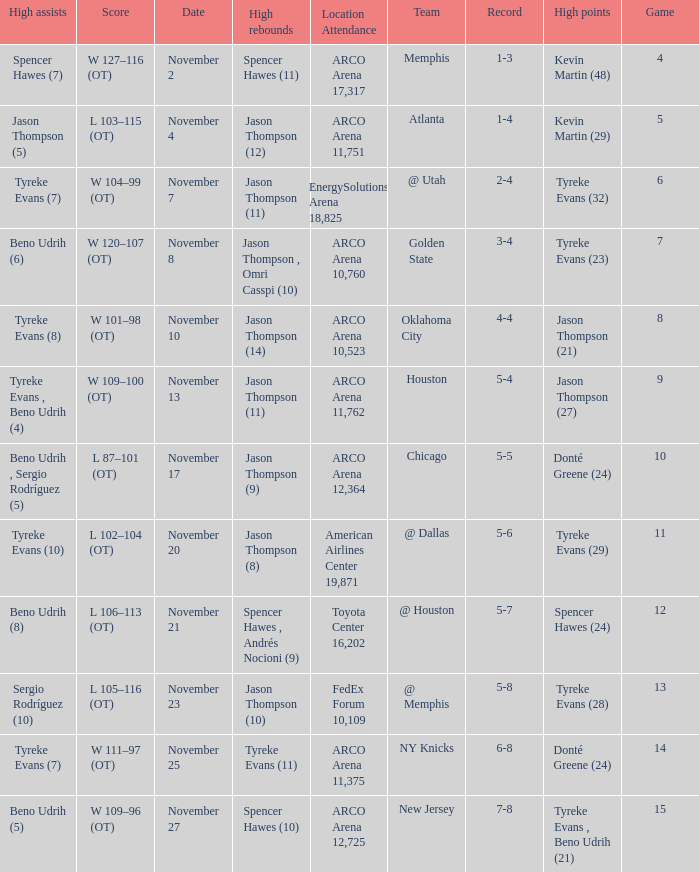If the record is 6-8, what was the score? W 111–97 (OT). 